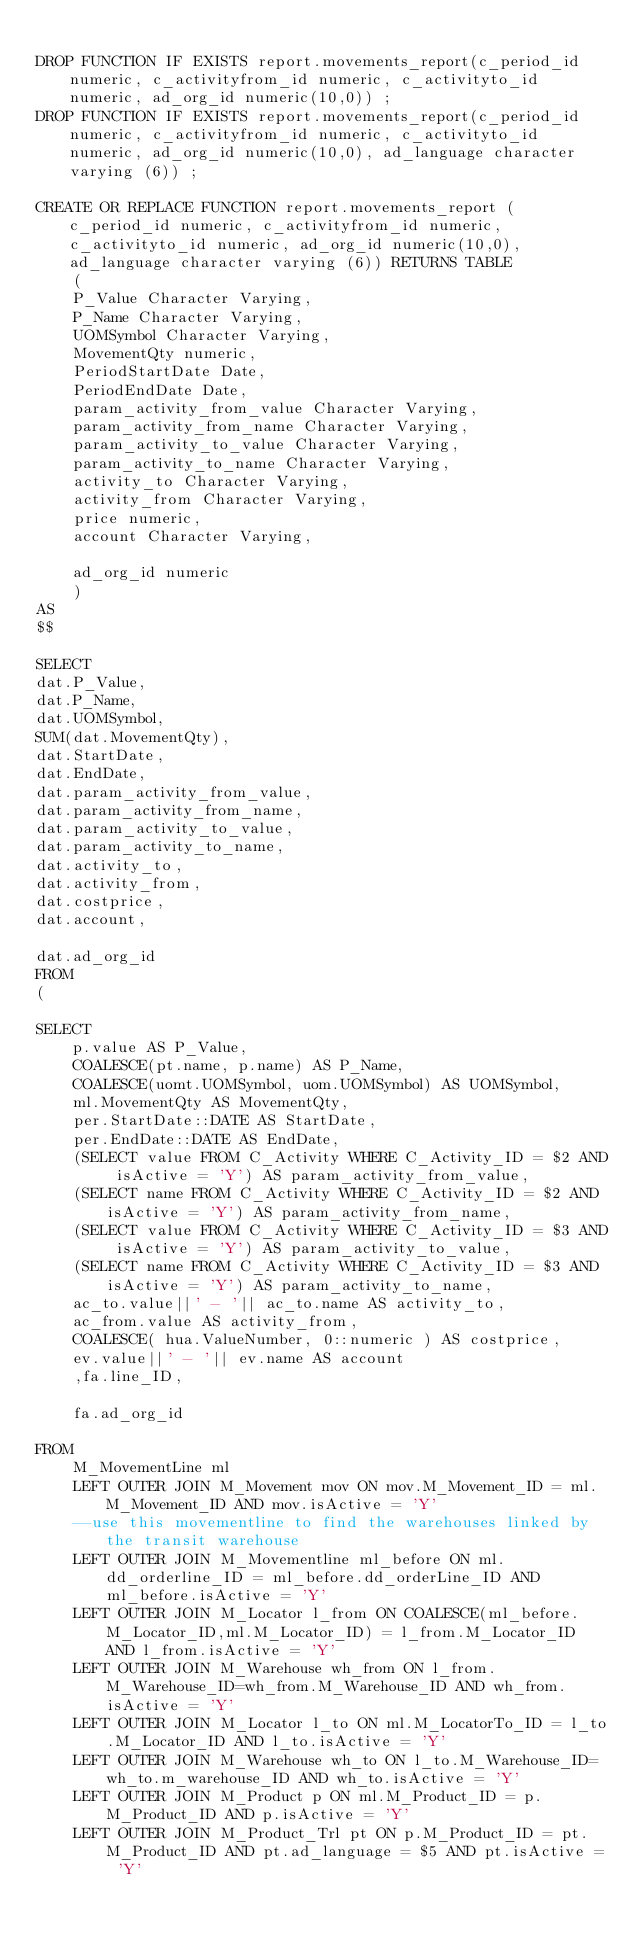Convert code to text. <code><loc_0><loc_0><loc_500><loc_500><_SQL_>
DROP FUNCTION IF EXISTS report.movements_report(c_period_id numeric, c_activityfrom_id numeric, c_activityto_id numeric, ad_org_id numeric(10,0)) ;
DROP FUNCTION IF EXISTS report.movements_report(c_period_id numeric, c_activityfrom_id numeric, c_activityto_id numeric, ad_org_id numeric(10,0), ad_language character varying (6)) ;

CREATE OR REPLACE FUNCTION report.movements_report (c_period_id numeric, c_activityfrom_id numeric, c_activityto_id numeric, ad_org_id numeric(10,0),ad_language character varying (6)) RETURNS TABLE
	(
	P_Value Character Varying, 
	P_Name Character Varying, 
	UOMSymbol Character Varying,
	MovementQty numeric,
	PeriodStartDate Date,
	PeriodEndDate Date,
	param_activity_from_value Character Varying,
	param_activity_from_name Character Varying,
	param_activity_to_value Character Varying,
	param_activity_to_name Character Varying,
	activity_to Character Varying,
	activity_from Character Varying,
	price numeric,
	account Character Varying,
	
	ad_org_id numeric
	)
AS 
$$

SELECT
dat.P_Value,
dat.P_Name,
dat.UOMSymbol,
SUM(dat.MovementQty),
dat.StartDate,
dat.EndDate,
dat.param_activity_from_value,
dat.param_activity_from_name,
dat.param_activity_to_value,
dat.param_activity_to_name,
dat.activity_to,
dat.activity_from,
dat.costprice,
dat.account,

dat.ad_org_id
FROM
(

SELECT
	p.value AS P_Value, 
	COALESCE(pt.name, p.name) AS P_Name, 
	COALESCE(uomt.UOMSymbol, uom.UOMSymbol) AS UOMSymbol, 
	ml.MovementQty AS MovementQty,
	per.StartDate::DATE AS StartDate,
	per.EndDate::DATE AS EndDate,
	(SELECT value FROM C_Activity WHERE C_Activity_ID = $2 AND isActive = 'Y') AS param_activity_from_value,
	(SELECT name FROM C_Activity WHERE C_Activity_ID = $2 AND isActive = 'Y') AS param_activity_from_name,
	(SELECT value FROM C_Activity WHERE C_Activity_ID = $3 AND isActive = 'Y') AS param_activity_to_value,
	(SELECT name FROM C_Activity WHERE C_Activity_ID = $3 AND isActive = 'Y') AS param_activity_to_name,
	ac_to.value||' - '|| ac_to.name AS activity_to,
	ac_from.value AS activity_from,
	COALESCE( hua.ValueNumber, 0::numeric ) AS costprice,
	ev.value||' - '|| ev.name AS account
	,fa.line_ID,
	
	fa.ad_org_id
	
FROM 
	M_MovementLine ml 
	LEFT OUTER JOIN M_Movement mov ON mov.M_Movement_ID = ml.M_Movement_ID AND mov.isActive = 'Y'
	--use this movementline to find the warehouses linked by the transit warehouse
	LEFT OUTER JOIN M_Movementline ml_before ON ml.dd_orderline_ID = ml_before.dd_orderLine_ID AND ml_before.isActive = 'Y'
	LEFT OUTER JOIN M_Locator l_from ON COALESCE(ml_before.M_Locator_ID,ml.M_Locator_ID) = l_from.M_Locator_ID AND l_from.isActive = 'Y'
	LEFT OUTER JOIN M_Warehouse wh_from ON l_from.M_Warehouse_ID=wh_from.M_Warehouse_ID AND wh_from.isActive = 'Y'
	LEFT OUTER JOIN M_Locator l_to ON ml.M_LocatorTo_ID = l_to.M_Locator_ID AND l_to.isActive = 'Y'
	LEFT OUTER JOIN M_Warehouse wh_to ON l_to.M_Warehouse_ID=wh_to.m_warehouse_ID AND wh_to.isActive = 'Y'
	LEFT OUTER JOIN M_Product p ON ml.M_Product_ID = p.M_Product_ID AND p.isActive = 'Y'
	LEFT OUTER JOIN M_Product_Trl pt ON p.M_Product_ID = pt.M_Product_ID AND pt.ad_language = $5 AND pt.isActive = 'Y'</code> 